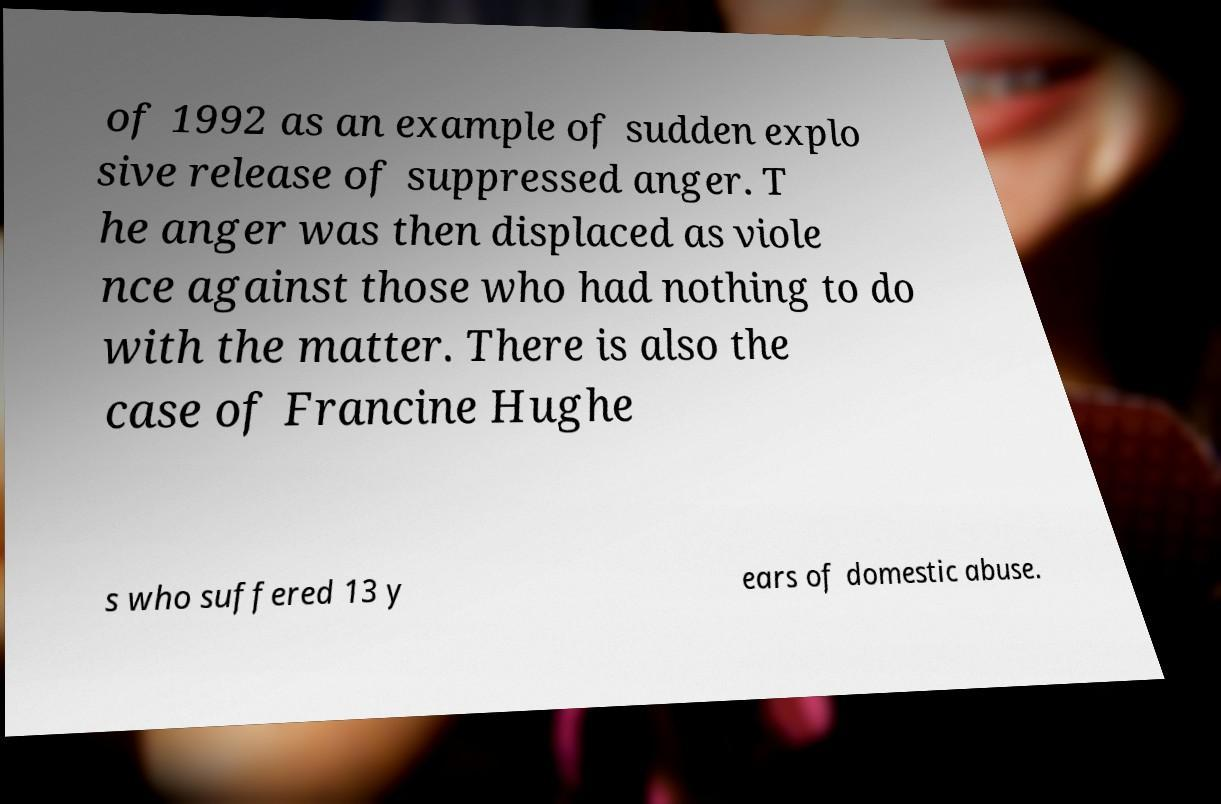For documentation purposes, I need the text within this image transcribed. Could you provide that? of 1992 as an example of sudden explo sive release of suppressed anger. T he anger was then displaced as viole nce against those who had nothing to do with the matter. There is also the case of Francine Hughe s who suffered 13 y ears of domestic abuse. 